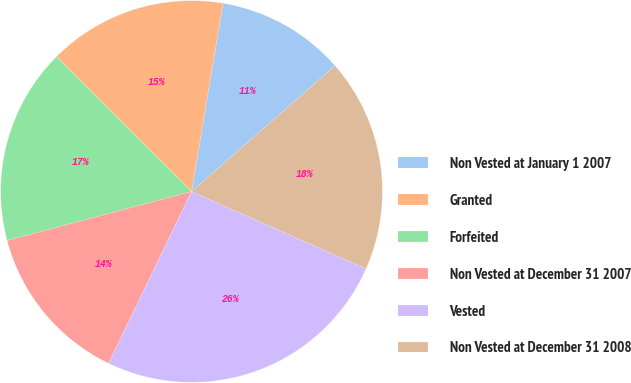Convert chart to OTSL. <chart><loc_0><loc_0><loc_500><loc_500><pie_chart><fcel>Non Vested at January 1 2007<fcel>Granted<fcel>Forfeited<fcel>Non Vested at December 31 2007<fcel>Vested<fcel>Non Vested at December 31 2008<nl><fcel>10.91%<fcel>15.16%<fcel>16.62%<fcel>13.7%<fcel>25.52%<fcel>18.08%<nl></chart> 